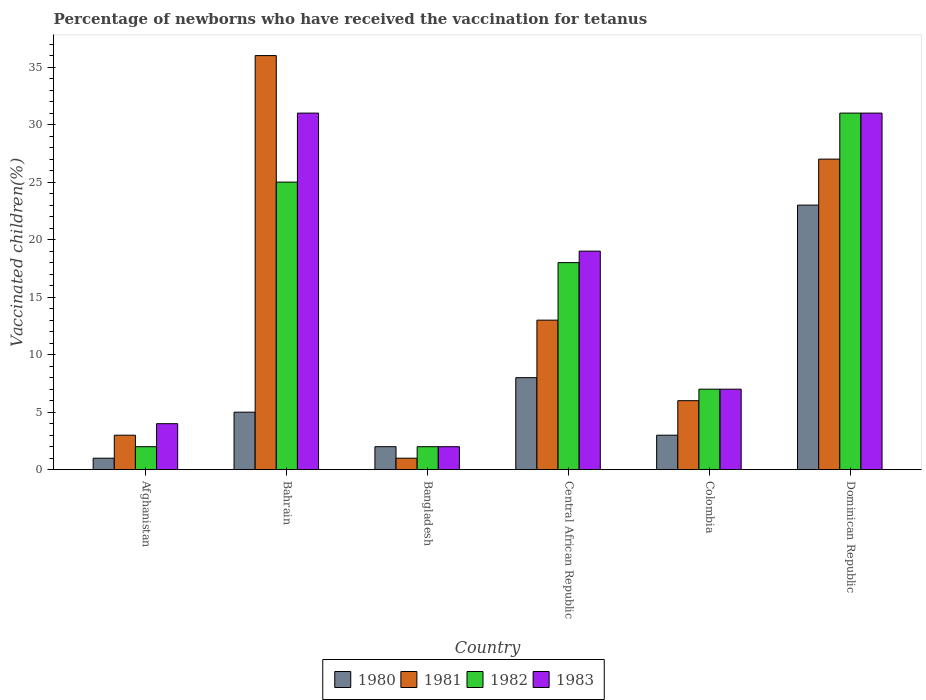How many groups of bars are there?
Make the answer very short. 6. Are the number of bars per tick equal to the number of legend labels?
Keep it short and to the point. Yes. How many bars are there on the 2nd tick from the left?
Make the answer very short. 4. How many bars are there on the 5th tick from the right?
Offer a very short reply. 4. In how many cases, is the number of bars for a given country not equal to the number of legend labels?
Offer a terse response. 0. What is the percentage of vaccinated children in 1983 in Dominican Republic?
Offer a very short reply. 31. In which country was the percentage of vaccinated children in 1983 maximum?
Your answer should be very brief. Bahrain. In which country was the percentage of vaccinated children in 1982 minimum?
Offer a terse response. Afghanistan. What is the difference between the percentage of vaccinated children in 1980 in Central African Republic and that in Dominican Republic?
Make the answer very short. -15. What is the difference between the percentage of vaccinated children in 1983 in Colombia and the percentage of vaccinated children in 1980 in Bangladesh?
Your response must be concise. 5. What is the average percentage of vaccinated children in 1982 per country?
Your answer should be very brief. 14.17. What is the ratio of the percentage of vaccinated children in 1981 in Bangladesh to that in Dominican Republic?
Your answer should be compact. 0.04. Is the percentage of vaccinated children in 1982 in Afghanistan less than that in Central African Republic?
Offer a very short reply. Yes. Is it the case that in every country, the sum of the percentage of vaccinated children in 1980 and percentage of vaccinated children in 1982 is greater than the sum of percentage of vaccinated children in 1983 and percentage of vaccinated children in 1981?
Ensure brevity in your answer.  No. What does the 1st bar from the left in Bangladesh represents?
Offer a very short reply. 1980. What does the 2nd bar from the right in Afghanistan represents?
Your answer should be very brief. 1982. What is the difference between two consecutive major ticks on the Y-axis?
Give a very brief answer. 5. Does the graph contain grids?
Ensure brevity in your answer.  No. Where does the legend appear in the graph?
Offer a very short reply. Bottom center. What is the title of the graph?
Make the answer very short. Percentage of newborns who have received the vaccination for tetanus. Does "1980" appear as one of the legend labels in the graph?
Provide a short and direct response. Yes. What is the label or title of the X-axis?
Your answer should be compact. Country. What is the label or title of the Y-axis?
Offer a terse response. Vaccinated children(%). What is the Vaccinated children(%) of 1981 in Afghanistan?
Ensure brevity in your answer.  3. What is the Vaccinated children(%) in 1981 in Bahrain?
Make the answer very short. 36. What is the Vaccinated children(%) of 1983 in Bahrain?
Provide a short and direct response. 31. What is the Vaccinated children(%) in 1980 in Bangladesh?
Provide a short and direct response. 2. What is the Vaccinated children(%) in 1981 in Bangladesh?
Offer a very short reply. 1. What is the Vaccinated children(%) in 1980 in Central African Republic?
Provide a short and direct response. 8. What is the Vaccinated children(%) of 1981 in Central African Republic?
Provide a short and direct response. 13. What is the Vaccinated children(%) in 1980 in Colombia?
Offer a very short reply. 3. What is the Vaccinated children(%) in 1982 in Colombia?
Your response must be concise. 7. What is the Vaccinated children(%) in 1983 in Colombia?
Provide a succinct answer. 7. What is the Vaccinated children(%) of 1981 in Dominican Republic?
Make the answer very short. 27. What is the Vaccinated children(%) in 1982 in Dominican Republic?
Keep it short and to the point. 31. What is the Vaccinated children(%) in 1983 in Dominican Republic?
Ensure brevity in your answer.  31. Across all countries, what is the maximum Vaccinated children(%) of 1980?
Offer a terse response. 23. Across all countries, what is the maximum Vaccinated children(%) in 1983?
Give a very brief answer. 31. Across all countries, what is the minimum Vaccinated children(%) in 1980?
Keep it short and to the point. 1. What is the total Vaccinated children(%) in 1980 in the graph?
Provide a succinct answer. 42. What is the total Vaccinated children(%) of 1982 in the graph?
Give a very brief answer. 85. What is the total Vaccinated children(%) of 1983 in the graph?
Provide a short and direct response. 94. What is the difference between the Vaccinated children(%) of 1980 in Afghanistan and that in Bahrain?
Your answer should be compact. -4. What is the difference between the Vaccinated children(%) of 1981 in Afghanistan and that in Bahrain?
Ensure brevity in your answer.  -33. What is the difference between the Vaccinated children(%) in 1982 in Afghanistan and that in Bahrain?
Make the answer very short. -23. What is the difference between the Vaccinated children(%) in 1983 in Afghanistan and that in Bangladesh?
Your response must be concise. 2. What is the difference between the Vaccinated children(%) of 1981 in Afghanistan and that in Central African Republic?
Offer a very short reply. -10. What is the difference between the Vaccinated children(%) in 1982 in Afghanistan and that in Central African Republic?
Make the answer very short. -16. What is the difference between the Vaccinated children(%) in 1983 in Afghanistan and that in Central African Republic?
Your answer should be very brief. -15. What is the difference between the Vaccinated children(%) in 1980 in Afghanistan and that in Colombia?
Give a very brief answer. -2. What is the difference between the Vaccinated children(%) of 1981 in Afghanistan and that in Colombia?
Give a very brief answer. -3. What is the difference between the Vaccinated children(%) in 1981 in Afghanistan and that in Dominican Republic?
Provide a succinct answer. -24. What is the difference between the Vaccinated children(%) in 1982 in Afghanistan and that in Dominican Republic?
Provide a short and direct response. -29. What is the difference between the Vaccinated children(%) in 1983 in Afghanistan and that in Dominican Republic?
Keep it short and to the point. -27. What is the difference between the Vaccinated children(%) in 1980 in Bahrain and that in Bangladesh?
Keep it short and to the point. 3. What is the difference between the Vaccinated children(%) of 1982 in Bahrain and that in Bangladesh?
Offer a very short reply. 23. What is the difference between the Vaccinated children(%) in 1980 in Bahrain and that in Central African Republic?
Provide a short and direct response. -3. What is the difference between the Vaccinated children(%) of 1982 in Bahrain and that in Central African Republic?
Offer a terse response. 7. What is the difference between the Vaccinated children(%) in 1981 in Bahrain and that in Colombia?
Make the answer very short. 30. What is the difference between the Vaccinated children(%) of 1980 in Bahrain and that in Dominican Republic?
Provide a short and direct response. -18. What is the difference between the Vaccinated children(%) of 1981 in Bahrain and that in Dominican Republic?
Keep it short and to the point. 9. What is the difference between the Vaccinated children(%) of 1981 in Bangladesh and that in Central African Republic?
Offer a very short reply. -12. What is the difference between the Vaccinated children(%) of 1982 in Bangladesh and that in Central African Republic?
Offer a terse response. -16. What is the difference between the Vaccinated children(%) in 1983 in Bangladesh and that in Central African Republic?
Your answer should be compact. -17. What is the difference between the Vaccinated children(%) in 1980 in Bangladesh and that in Dominican Republic?
Offer a terse response. -21. What is the difference between the Vaccinated children(%) in 1981 in Bangladesh and that in Dominican Republic?
Offer a very short reply. -26. What is the difference between the Vaccinated children(%) in 1983 in Bangladesh and that in Dominican Republic?
Provide a short and direct response. -29. What is the difference between the Vaccinated children(%) of 1980 in Central African Republic and that in Colombia?
Make the answer very short. 5. What is the difference between the Vaccinated children(%) in 1981 in Central African Republic and that in Colombia?
Keep it short and to the point. 7. What is the difference between the Vaccinated children(%) in 1982 in Colombia and that in Dominican Republic?
Keep it short and to the point. -24. What is the difference between the Vaccinated children(%) in 1983 in Colombia and that in Dominican Republic?
Keep it short and to the point. -24. What is the difference between the Vaccinated children(%) in 1980 in Afghanistan and the Vaccinated children(%) in 1981 in Bahrain?
Provide a short and direct response. -35. What is the difference between the Vaccinated children(%) in 1980 in Afghanistan and the Vaccinated children(%) in 1982 in Bahrain?
Make the answer very short. -24. What is the difference between the Vaccinated children(%) in 1980 in Afghanistan and the Vaccinated children(%) in 1983 in Bahrain?
Provide a succinct answer. -30. What is the difference between the Vaccinated children(%) in 1981 in Afghanistan and the Vaccinated children(%) in 1982 in Bahrain?
Offer a terse response. -22. What is the difference between the Vaccinated children(%) of 1981 in Afghanistan and the Vaccinated children(%) of 1983 in Bahrain?
Give a very brief answer. -28. What is the difference between the Vaccinated children(%) in 1982 in Afghanistan and the Vaccinated children(%) in 1983 in Bahrain?
Your answer should be compact. -29. What is the difference between the Vaccinated children(%) in 1980 in Afghanistan and the Vaccinated children(%) in 1982 in Bangladesh?
Your answer should be compact. -1. What is the difference between the Vaccinated children(%) of 1980 in Afghanistan and the Vaccinated children(%) of 1981 in Central African Republic?
Your response must be concise. -12. What is the difference between the Vaccinated children(%) of 1980 in Afghanistan and the Vaccinated children(%) of 1983 in Central African Republic?
Your answer should be compact. -18. What is the difference between the Vaccinated children(%) in 1980 in Afghanistan and the Vaccinated children(%) in 1981 in Colombia?
Provide a succinct answer. -5. What is the difference between the Vaccinated children(%) in 1980 in Afghanistan and the Vaccinated children(%) in 1982 in Colombia?
Ensure brevity in your answer.  -6. What is the difference between the Vaccinated children(%) of 1980 in Afghanistan and the Vaccinated children(%) of 1983 in Colombia?
Ensure brevity in your answer.  -6. What is the difference between the Vaccinated children(%) in 1981 in Afghanistan and the Vaccinated children(%) in 1982 in Colombia?
Keep it short and to the point. -4. What is the difference between the Vaccinated children(%) in 1980 in Afghanistan and the Vaccinated children(%) in 1981 in Dominican Republic?
Your response must be concise. -26. What is the difference between the Vaccinated children(%) of 1980 in Afghanistan and the Vaccinated children(%) of 1983 in Dominican Republic?
Provide a succinct answer. -30. What is the difference between the Vaccinated children(%) of 1981 in Afghanistan and the Vaccinated children(%) of 1982 in Dominican Republic?
Make the answer very short. -28. What is the difference between the Vaccinated children(%) of 1981 in Afghanistan and the Vaccinated children(%) of 1983 in Dominican Republic?
Your answer should be compact. -28. What is the difference between the Vaccinated children(%) in 1981 in Bahrain and the Vaccinated children(%) in 1982 in Bangladesh?
Your response must be concise. 34. What is the difference between the Vaccinated children(%) in 1980 in Bahrain and the Vaccinated children(%) in 1981 in Central African Republic?
Give a very brief answer. -8. What is the difference between the Vaccinated children(%) of 1980 in Bahrain and the Vaccinated children(%) of 1982 in Central African Republic?
Offer a terse response. -13. What is the difference between the Vaccinated children(%) of 1980 in Bahrain and the Vaccinated children(%) of 1983 in Central African Republic?
Offer a very short reply. -14. What is the difference between the Vaccinated children(%) of 1981 in Bahrain and the Vaccinated children(%) of 1983 in Central African Republic?
Keep it short and to the point. 17. What is the difference between the Vaccinated children(%) of 1982 in Bahrain and the Vaccinated children(%) of 1983 in Central African Republic?
Provide a short and direct response. 6. What is the difference between the Vaccinated children(%) of 1980 in Bahrain and the Vaccinated children(%) of 1981 in Colombia?
Your response must be concise. -1. What is the difference between the Vaccinated children(%) in 1980 in Bahrain and the Vaccinated children(%) in 1982 in Colombia?
Offer a terse response. -2. What is the difference between the Vaccinated children(%) of 1982 in Bahrain and the Vaccinated children(%) of 1983 in Colombia?
Your answer should be very brief. 18. What is the difference between the Vaccinated children(%) of 1980 in Bahrain and the Vaccinated children(%) of 1981 in Dominican Republic?
Offer a terse response. -22. What is the difference between the Vaccinated children(%) in 1980 in Bahrain and the Vaccinated children(%) in 1982 in Dominican Republic?
Ensure brevity in your answer.  -26. What is the difference between the Vaccinated children(%) of 1980 in Bangladesh and the Vaccinated children(%) of 1983 in Central African Republic?
Offer a very short reply. -17. What is the difference between the Vaccinated children(%) of 1981 in Bangladesh and the Vaccinated children(%) of 1982 in Central African Republic?
Make the answer very short. -17. What is the difference between the Vaccinated children(%) in 1982 in Bangladesh and the Vaccinated children(%) in 1983 in Central African Republic?
Offer a very short reply. -17. What is the difference between the Vaccinated children(%) in 1980 in Bangladesh and the Vaccinated children(%) in 1983 in Colombia?
Provide a short and direct response. -5. What is the difference between the Vaccinated children(%) in 1982 in Bangladesh and the Vaccinated children(%) in 1983 in Colombia?
Your answer should be very brief. -5. What is the difference between the Vaccinated children(%) of 1980 in Bangladesh and the Vaccinated children(%) of 1981 in Dominican Republic?
Give a very brief answer. -25. What is the difference between the Vaccinated children(%) in 1980 in Bangladesh and the Vaccinated children(%) in 1983 in Dominican Republic?
Offer a very short reply. -29. What is the difference between the Vaccinated children(%) in 1980 in Central African Republic and the Vaccinated children(%) in 1982 in Colombia?
Give a very brief answer. 1. What is the difference between the Vaccinated children(%) of 1981 in Central African Republic and the Vaccinated children(%) of 1983 in Colombia?
Your response must be concise. 6. What is the difference between the Vaccinated children(%) of 1980 in Central African Republic and the Vaccinated children(%) of 1981 in Dominican Republic?
Provide a succinct answer. -19. What is the difference between the Vaccinated children(%) in 1981 in Central African Republic and the Vaccinated children(%) in 1983 in Dominican Republic?
Make the answer very short. -18. What is the difference between the Vaccinated children(%) in 1982 in Central African Republic and the Vaccinated children(%) in 1983 in Dominican Republic?
Make the answer very short. -13. What is the difference between the Vaccinated children(%) of 1980 in Colombia and the Vaccinated children(%) of 1982 in Dominican Republic?
Your answer should be compact. -28. What is the difference between the Vaccinated children(%) in 1980 in Colombia and the Vaccinated children(%) in 1983 in Dominican Republic?
Make the answer very short. -28. What is the average Vaccinated children(%) of 1980 per country?
Give a very brief answer. 7. What is the average Vaccinated children(%) of 1981 per country?
Make the answer very short. 14.33. What is the average Vaccinated children(%) in 1982 per country?
Offer a very short reply. 14.17. What is the average Vaccinated children(%) in 1983 per country?
Provide a short and direct response. 15.67. What is the difference between the Vaccinated children(%) of 1980 and Vaccinated children(%) of 1981 in Afghanistan?
Your answer should be very brief. -2. What is the difference between the Vaccinated children(%) of 1980 and Vaccinated children(%) of 1981 in Bahrain?
Your answer should be very brief. -31. What is the difference between the Vaccinated children(%) in 1980 and Vaccinated children(%) in 1983 in Bahrain?
Provide a succinct answer. -26. What is the difference between the Vaccinated children(%) of 1982 and Vaccinated children(%) of 1983 in Bangladesh?
Provide a succinct answer. 0. What is the difference between the Vaccinated children(%) in 1980 and Vaccinated children(%) in 1981 in Central African Republic?
Your answer should be very brief. -5. What is the difference between the Vaccinated children(%) in 1980 and Vaccinated children(%) in 1982 in Central African Republic?
Provide a succinct answer. -10. What is the difference between the Vaccinated children(%) of 1980 and Vaccinated children(%) of 1983 in Central African Republic?
Your answer should be compact. -11. What is the difference between the Vaccinated children(%) in 1980 and Vaccinated children(%) in 1981 in Colombia?
Your answer should be very brief. -3. What is the difference between the Vaccinated children(%) of 1980 and Vaccinated children(%) of 1982 in Colombia?
Your answer should be compact. -4. What is the difference between the Vaccinated children(%) in 1982 and Vaccinated children(%) in 1983 in Colombia?
Keep it short and to the point. 0. What is the difference between the Vaccinated children(%) in 1980 and Vaccinated children(%) in 1981 in Dominican Republic?
Keep it short and to the point. -4. What is the difference between the Vaccinated children(%) in 1980 and Vaccinated children(%) in 1983 in Dominican Republic?
Give a very brief answer. -8. What is the difference between the Vaccinated children(%) in 1981 and Vaccinated children(%) in 1982 in Dominican Republic?
Your answer should be very brief. -4. What is the difference between the Vaccinated children(%) in 1981 and Vaccinated children(%) in 1983 in Dominican Republic?
Your response must be concise. -4. What is the ratio of the Vaccinated children(%) in 1980 in Afghanistan to that in Bahrain?
Give a very brief answer. 0.2. What is the ratio of the Vaccinated children(%) of 1981 in Afghanistan to that in Bahrain?
Provide a short and direct response. 0.08. What is the ratio of the Vaccinated children(%) in 1982 in Afghanistan to that in Bahrain?
Keep it short and to the point. 0.08. What is the ratio of the Vaccinated children(%) in 1983 in Afghanistan to that in Bahrain?
Ensure brevity in your answer.  0.13. What is the ratio of the Vaccinated children(%) of 1980 in Afghanistan to that in Bangladesh?
Keep it short and to the point. 0.5. What is the ratio of the Vaccinated children(%) of 1983 in Afghanistan to that in Bangladesh?
Offer a very short reply. 2. What is the ratio of the Vaccinated children(%) of 1981 in Afghanistan to that in Central African Republic?
Keep it short and to the point. 0.23. What is the ratio of the Vaccinated children(%) in 1982 in Afghanistan to that in Central African Republic?
Ensure brevity in your answer.  0.11. What is the ratio of the Vaccinated children(%) of 1983 in Afghanistan to that in Central African Republic?
Your response must be concise. 0.21. What is the ratio of the Vaccinated children(%) of 1981 in Afghanistan to that in Colombia?
Give a very brief answer. 0.5. What is the ratio of the Vaccinated children(%) of 1982 in Afghanistan to that in Colombia?
Provide a short and direct response. 0.29. What is the ratio of the Vaccinated children(%) of 1983 in Afghanistan to that in Colombia?
Provide a succinct answer. 0.57. What is the ratio of the Vaccinated children(%) of 1980 in Afghanistan to that in Dominican Republic?
Give a very brief answer. 0.04. What is the ratio of the Vaccinated children(%) in 1982 in Afghanistan to that in Dominican Republic?
Your answer should be compact. 0.06. What is the ratio of the Vaccinated children(%) in 1983 in Afghanistan to that in Dominican Republic?
Make the answer very short. 0.13. What is the ratio of the Vaccinated children(%) of 1980 in Bahrain to that in Bangladesh?
Ensure brevity in your answer.  2.5. What is the ratio of the Vaccinated children(%) of 1981 in Bahrain to that in Bangladesh?
Give a very brief answer. 36. What is the ratio of the Vaccinated children(%) in 1982 in Bahrain to that in Bangladesh?
Your response must be concise. 12.5. What is the ratio of the Vaccinated children(%) of 1980 in Bahrain to that in Central African Republic?
Your answer should be compact. 0.62. What is the ratio of the Vaccinated children(%) of 1981 in Bahrain to that in Central African Republic?
Your answer should be compact. 2.77. What is the ratio of the Vaccinated children(%) in 1982 in Bahrain to that in Central African Republic?
Your answer should be compact. 1.39. What is the ratio of the Vaccinated children(%) in 1983 in Bahrain to that in Central African Republic?
Your response must be concise. 1.63. What is the ratio of the Vaccinated children(%) of 1982 in Bahrain to that in Colombia?
Offer a terse response. 3.57. What is the ratio of the Vaccinated children(%) in 1983 in Bahrain to that in Colombia?
Offer a terse response. 4.43. What is the ratio of the Vaccinated children(%) in 1980 in Bahrain to that in Dominican Republic?
Provide a short and direct response. 0.22. What is the ratio of the Vaccinated children(%) of 1982 in Bahrain to that in Dominican Republic?
Provide a short and direct response. 0.81. What is the ratio of the Vaccinated children(%) of 1980 in Bangladesh to that in Central African Republic?
Your answer should be very brief. 0.25. What is the ratio of the Vaccinated children(%) of 1981 in Bangladesh to that in Central African Republic?
Your answer should be very brief. 0.08. What is the ratio of the Vaccinated children(%) of 1983 in Bangladesh to that in Central African Republic?
Keep it short and to the point. 0.11. What is the ratio of the Vaccinated children(%) in 1980 in Bangladesh to that in Colombia?
Offer a very short reply. 0.67. What is the ratio of the Vaccinated children(%) in 1981 in Bangladesh to that in Colombia?
Make the answer very short. 0.17. What is the ratio of the Vaccinated children(%) of 1982 in Bangladesh to that in Colombia?
Keep it short and to the point. 0.29. What is the ratio of the Vaccinated children(%) of 1983 in Bangladesh to that in Colombia?
Keep it short and to the point. 0.29. What is the ratio of the Vaccinated children(%) of 1980 in Bangladesh to that in Dominican Republic?
Your answer should be very brief. 0.09. What is the ratio of the Vaccinated children(%) in 1981 in Bangladesh to that in Dominican Republic?
Your answer should be compact. 0.04. What is the ratio of the Vaccinated children(%) in 1982 in Bangladesh to that in Dominican Republic?
Make the answer very short. 0.06. What is the ratio of the Vaccinated children(%) in 1983 in Bangladesh to that in Dominican Republic?
Your answer should be compact. 0.06. What is the ratio of the Vaccinated children(%) in 1980 in Central African Republic to that in Colombia?
Make the answer very short. 2.67. What is the ratio of the Vaccinated children(%) in 1981 in Central African Republic to that in Colombia?
Ensure brevity in your answer.  2.17. What is the ratio of the Vaccinated children(%) in 1982 in Central African Republic to that in Colombia?
Your response must be concise. 2.57. What is the ratio of the Vaccinated children(%) of 1983 in Central African Republic to that in Colombia?
Offer a very short reply. 2.71. What is the ratio of the Vaccinated children(%) of 1980 in Central African Republic to that in Dominican Republic?
Your answer should be compact. 0.35. What is the ratio of the Vaccinated children(%) in 1981 in Central African Republic to that in Dominican Republic?
Your answer should be very brief. 0.48. What is the ratio of the Vaccinated children(%) of 1982 in Central African Republic to that in Dominican Republic?
Offer a terse response. 0.58. What is the ratio of the Vaccinated children(%) of 1983 in Central African Republic to that in Dominican Republic?
Your answer should be very brief. 0.61. What is the ratio of the Vaccinated children(%) in 1980 in Colombia to that in Dominican Republic?
Ensure brevity in your answer.  0.13. What is the ratio of the Vaccinated children(%) of 1981 in Colombia to that in Dominican Republic?
Keep it short and to the point. 0.22. What is the ratio of the Vaccinated children(%) of 1982 in Colombia to that in Dominican Republic?
Your response must be concise. 0.23. What is the ratio of the Vaccinated children(%) of 1983 in Colombia to that in Dominican Republic?
Your answer should be compact. 0.23. What is the difference between the highest and the second highest Vaccinated children(%) of 1980?
Provide a succinct answer. 15. What is the difference between the highest and the second highest Vaccinated children(%) of 1982?
Ensure brevity in your answer.  6. What is the difference between the highest and the second highest Vaccinated children(%) of 1983?
Your answer should be compact. 0. What is the difference between the highest and the lowest Vaccinated children(%) in 1980?
Your answer should be very brief. 22. What is the difference between the highest and the lowest Vaccinated children(%) in 1981?
Offer a terse response. 35. What is the difference between the highest and the lowest Vaccinated children(%) in 1982?
Ensure brevity in your answer.  29. What is the difference between the highest and the lowest Vaccinated children(%) in 1983?
Keep it short and to the point. 29. 